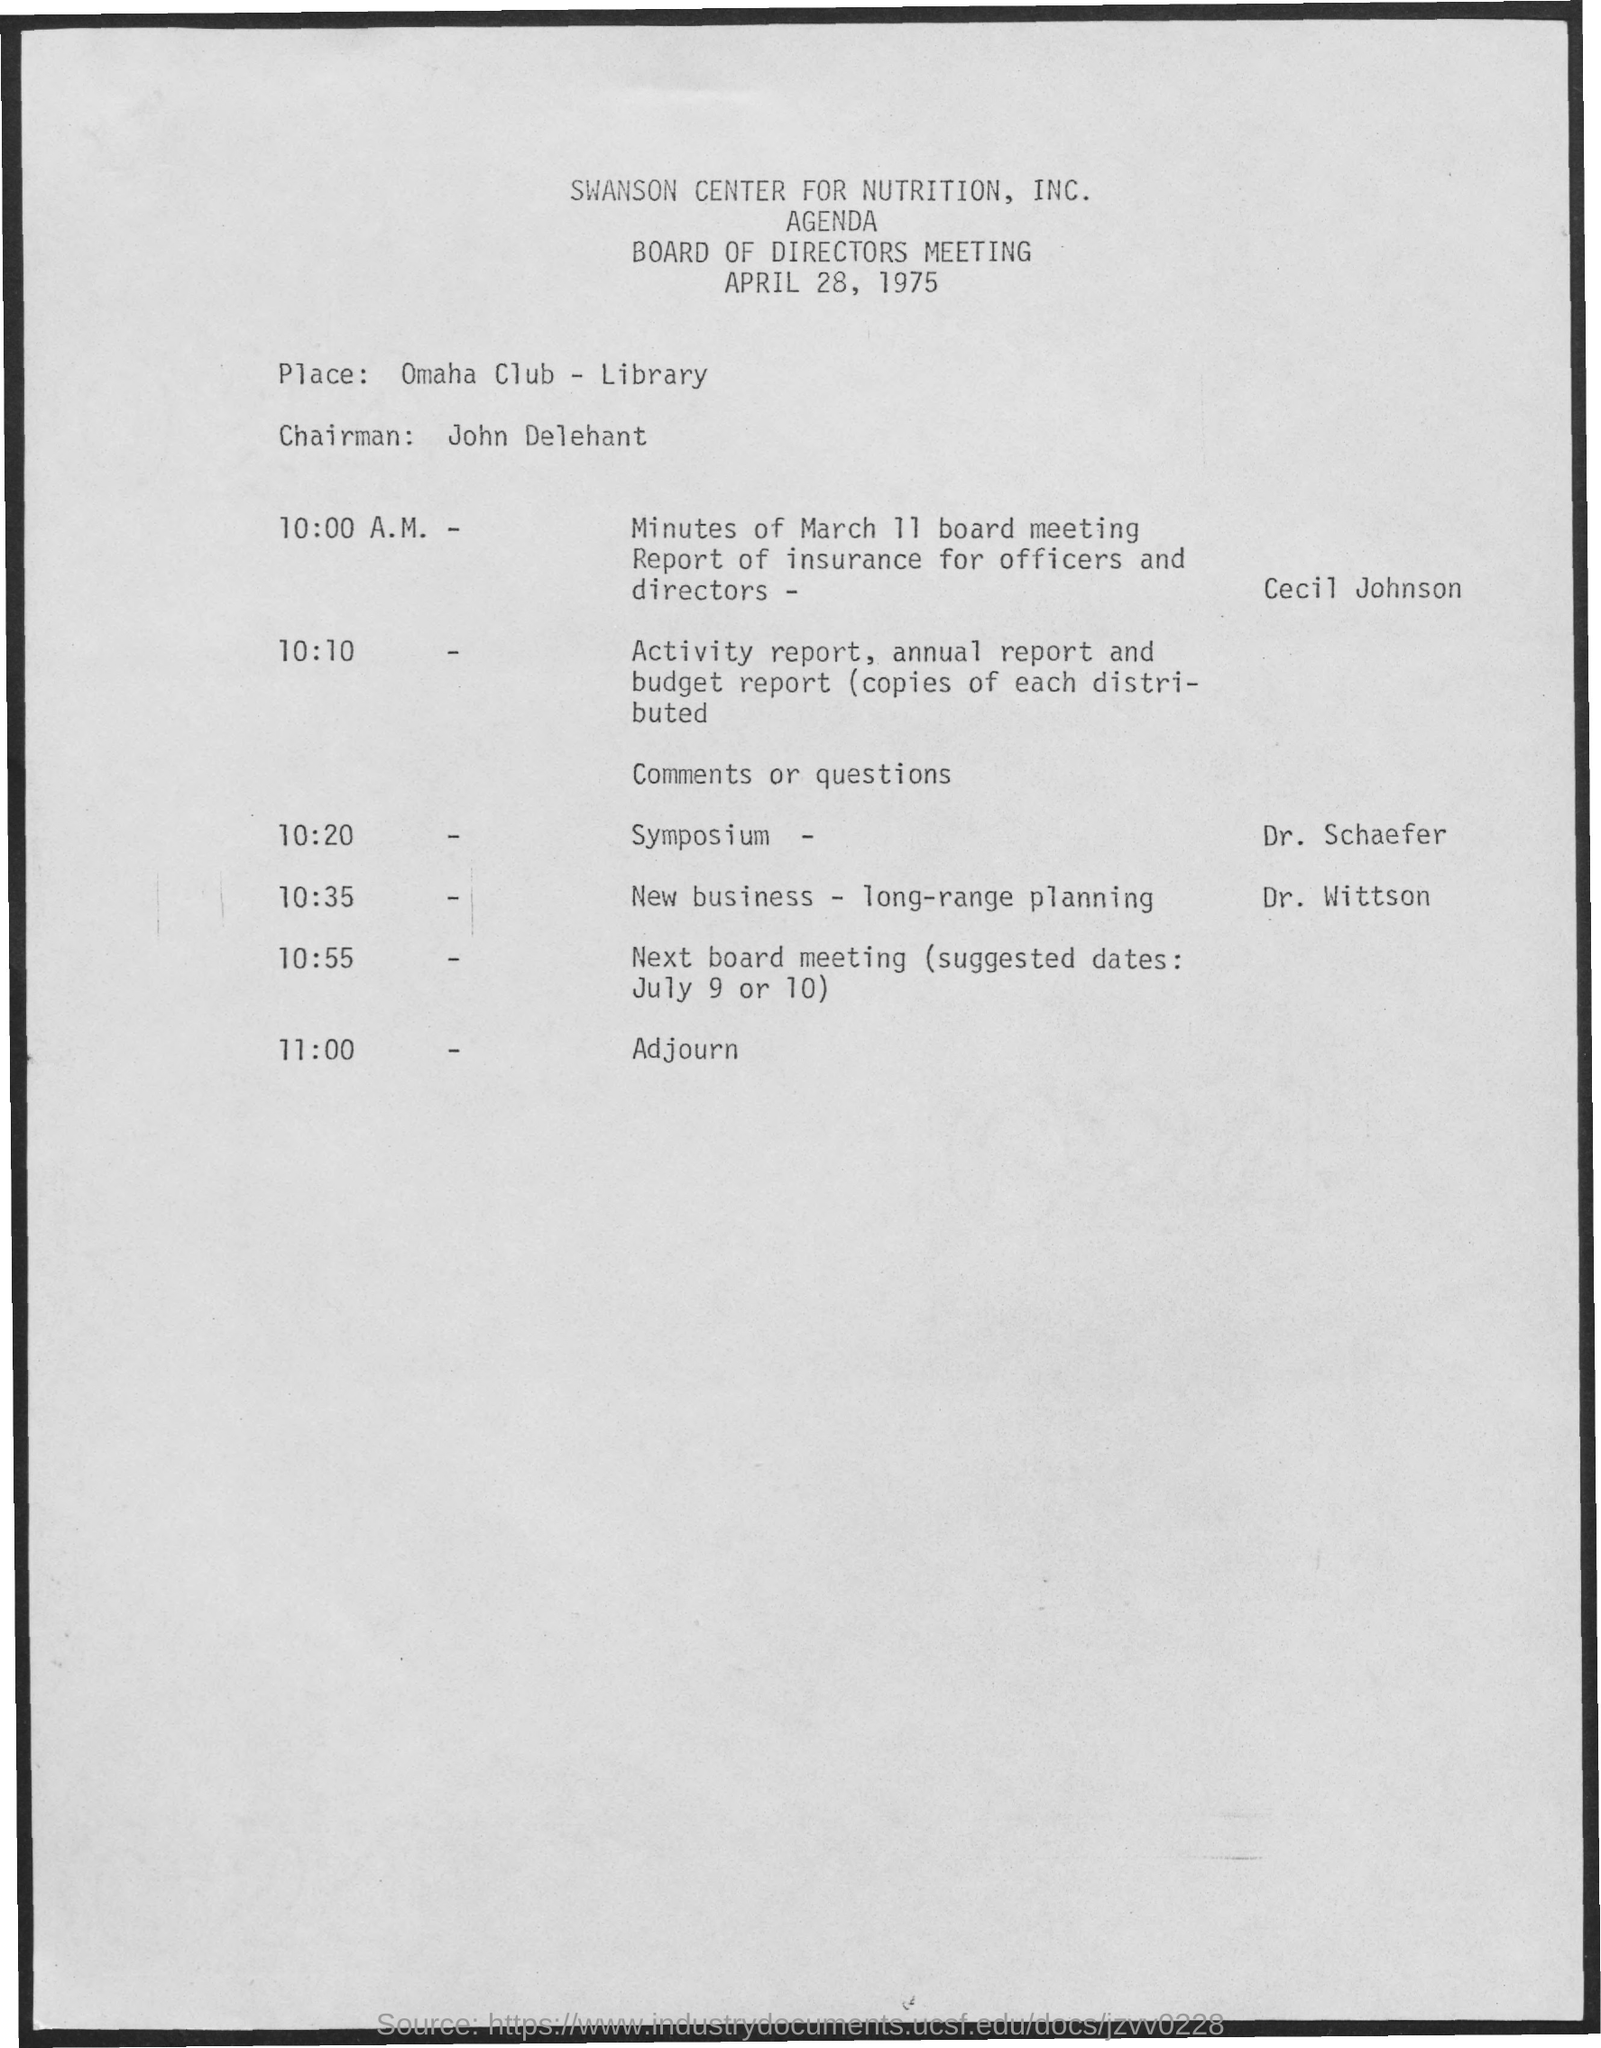When is the meeting?
Provide a succinct answer. April 28, 1975. Which is the Place?
Your response must be concise. Omaha Club - Library. Who is the Chairman?
Your response must be concise. John Delehant. When is the Symposium?
Your answer should be very brief. 10:20. Who is presenting the symposium?
Offer a terse response. Dr. Schaefer. When is the Adjourn?
Make the answer very short. 11:00. When is the New Business - long-range planning?
Keep it short and to the point. 10:35. Who is presenting the New Business - long-range planning?
Offer a terse response. Dr. Wittson. 